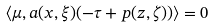Convert formula to latex. <formula><loc_0><loc_0><loc_500><loc_500>\langle \mu , a ( x , \xi ) ( - \tau + p ( z , \zeta ) ) \rangle = 0</formula> 